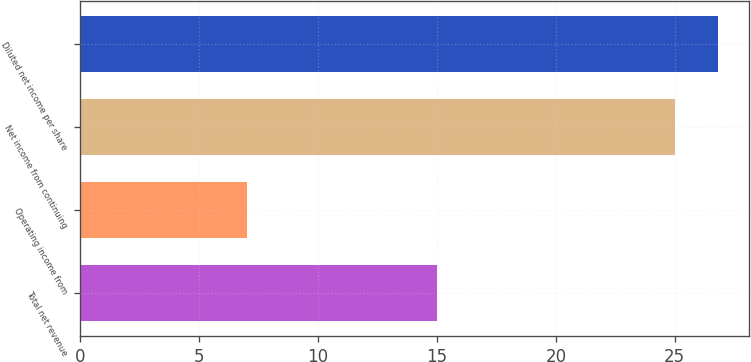Convert chart. <chart><loc_0><loc_0><loc_500><loc_500><bar_chart><fcel>Total net revenue<fcel>Operating income from<fcel>Net income from continuing<fcel>Diluted net income per share<nl><fcel>15<fcel>7<fcel>25<fcel>26.8<nl></chart> 